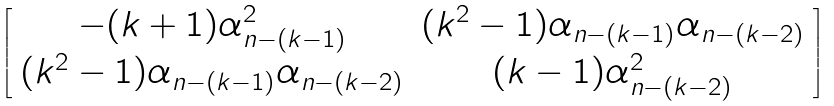<formula> <loc_0><loc_0><loc_500><loc_500>\left [ \begin{array} { c c } - ( k + 1 ) \alpha _ { n - ( k - 1 ) } ^ { 2 } & ( k ^ { 2 } - 1 ) \alpha _ { n - ( k - 1 ) } \alpha _ { n - ( k - 2 ) } \\ ( k ^ { 2 } - 1 ) \alpha _ { n - ( k - 1 ) } \alpha _ { n - ( k - 2 ) } & ( k - 1 ) \alpha _ { n - ( k - 2 ) } ^ { 2 } \end{array} \right ]</formula> 